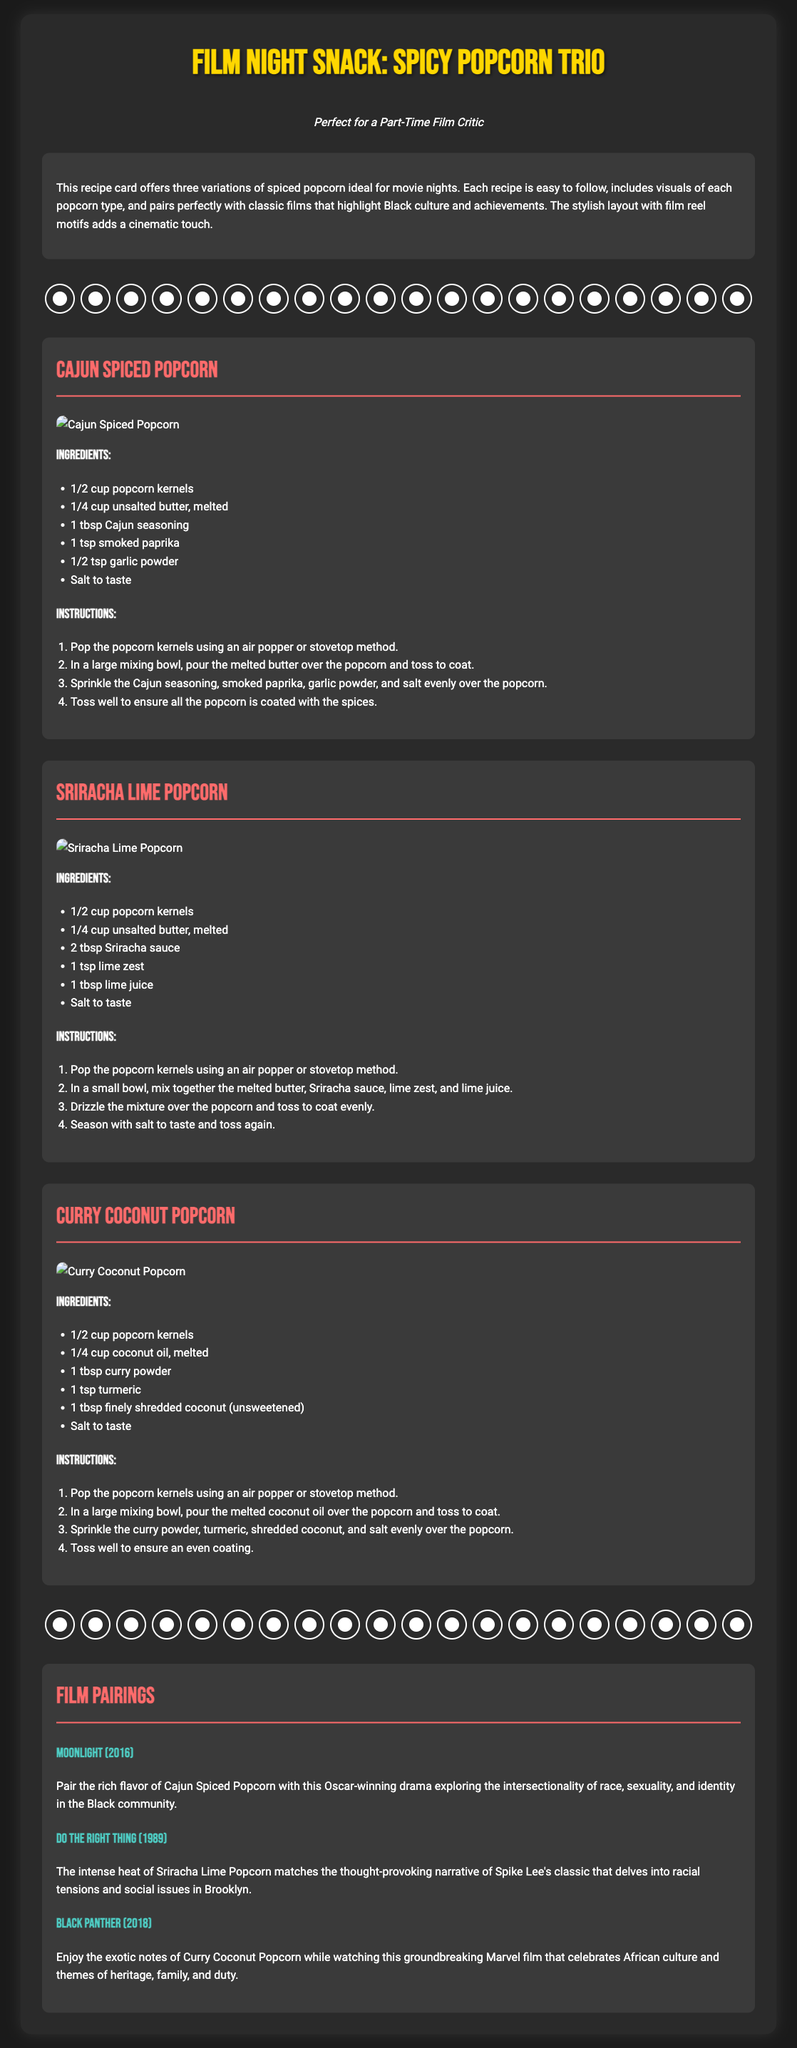what are the three popcorn variations? The document lists three variations: Cajun Spiced Popcorn, Sriracha Lime Popcorn, and Curry Coconut Popcorn.
Answer: Cajun Spiced Popcorn, Sriracha Lime Popcorn, Curry Coconut Popcorn how much butter is needed for Cajun Spiced Popcorn? The recipe for Cajun Spiced Popcorn calls for 1/4 cup of unsalted butter, melted.
Answer: 1/4 cup what film pairs with Curry Coconut Popcorn? The document states that Curry Coconut Popcorn pairs with the film Black Panther (2018).
Answer: Black Panther (2018) how much Sriracha sauce is used in Sriracha Lime Popcorn? The recipe specifies using 2 tablespoons of Sriracha sauce for Sriracha Lime Popcorn.
Answer: 2 tablespoons what is the main seasoning used in Cajun Spiced Popcorn? The main seasoning mentioned for Cajun Spiced Popcorn is Cajun seasoning.
Answer: Cajun seasoning which film is paired with Sriracha Lime Popcorn? Sriracha Lime Popcorn is paired with Do the Right Thing (1989).
Answer: Do the Right Thing (1989) what type of oil is used in the Curry Coconut Popcorn recipe? The recipe for Curry Coconut Popcorn uses melted coconut oil.
Answer: coconut oil how many steps are in the instructions for each popcorn recipe? Each popcorn recipe has four steps in the instructions.
Answer: four steps 